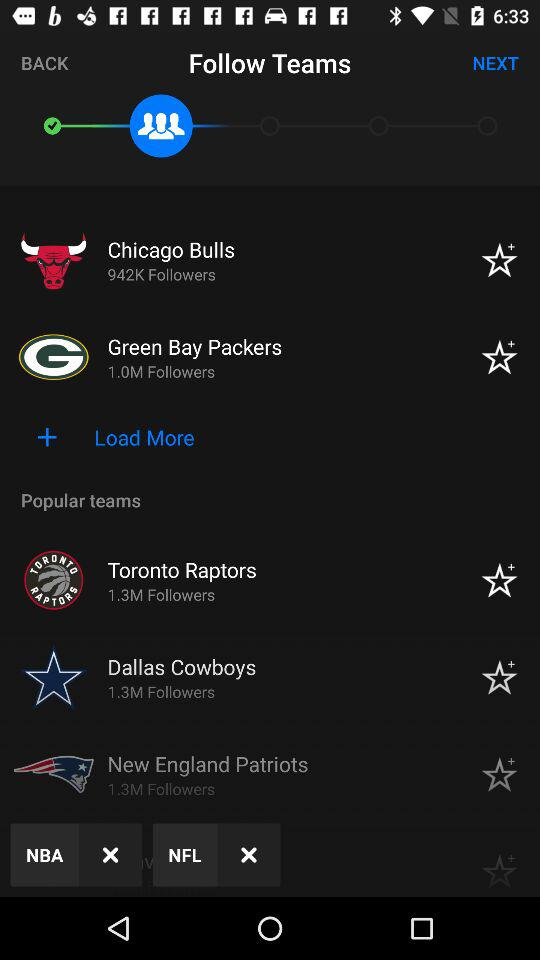What are the popular team's names? The popular teams are "Toronto Raptors", "Dallas Cowboys" and "New England Patriots". 